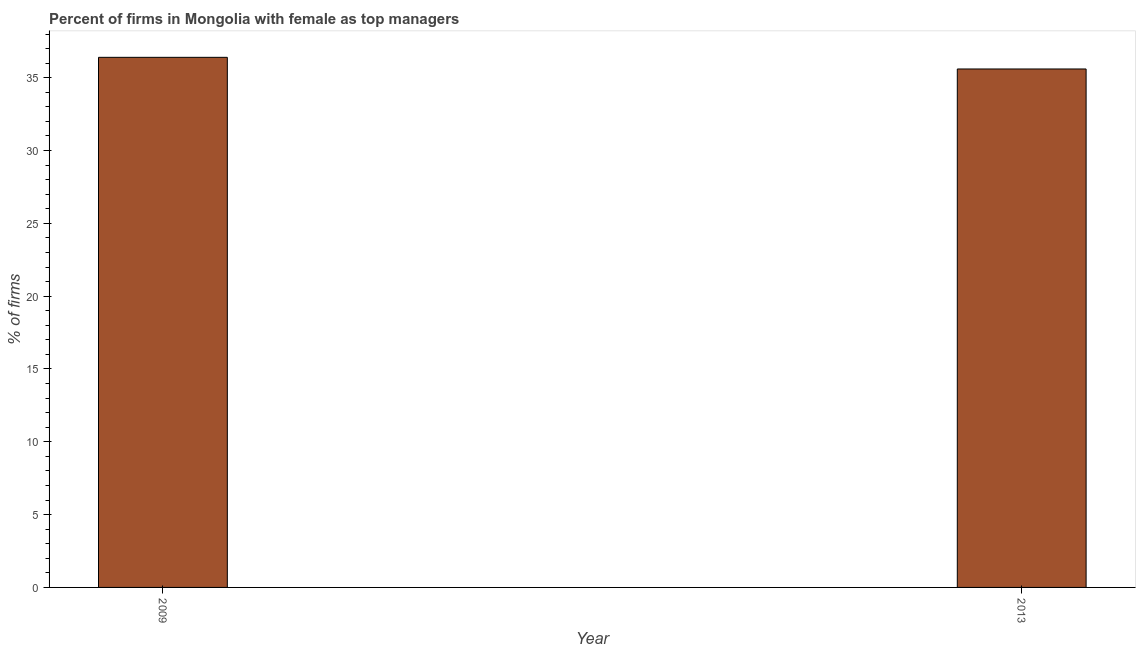Does the graph contain grids?
Your answer should be very brief. No. What is the title of the graph?
Make the answer very short. Percent of firms in Mongolia with female as top managers. What is the label or title of the X-axis?
Give a very brief answer. Year. What is the label or title of the Y-axis?
Offer a terse response. % of firms. What is the percentage of firms with female as top manager in 2009?
Ensure brevity in your answer.  36.4. Across all years, what is the maximum percentage of firms with female as top manager?
Provide a short and direct response. 36.4. Across all years, what is the minimum percentage of firms with female as top manager?
Give a very brief answer. 35.6. In which year was the percentage of firms with female as top manager minimum?
Ensure brevity in your answer.  2013. What is the sum of the percentage of firms with female as top manager?
Your response must be concise. 72. What is the difference between the percentage of firms with female as top manager in 2009 and 2013?
Make the answer very short. 0.8. In how many years, is the percentage of firms with female as top manager greater than 16 %?
Ensure brevity in your answer.  2. Do a majority of the years between 2009 and 2013 (inclusive) have percentage of firms with female as top manager greater than 6 %?
Offer a terse response. Yes. What is the ratio of the percentage of firms with female as top manager in 2009 to that in 2013?
Provide a succinct answer. 1.02. What is the difference between two consecutive major ticks on the Y-axis?
Offer a very short reply. 5. What is the % of firms in 2009?
Provide a succinct answer. 36.4. What is the % of firms in 2013?
Provide a succinct answer. 35.6. What is the difference between the % of firms in 2009 and 2013?
Keep it short and to the point. 0.8. 